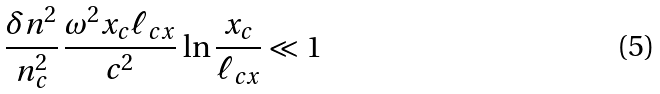<formula> <loc_0><loc_0><loc_500><loc_500>\frac { \delta n ^ { 2 } } { n _ { c } ^ { 2 } } \, \frac { \omega ^ { 2 } x _ { c } \ell _ { c x } } { c ^ { 2 } } \, \ln \frac { x _ { c } } { \ell _ { c x } } \ll 1</formula> 